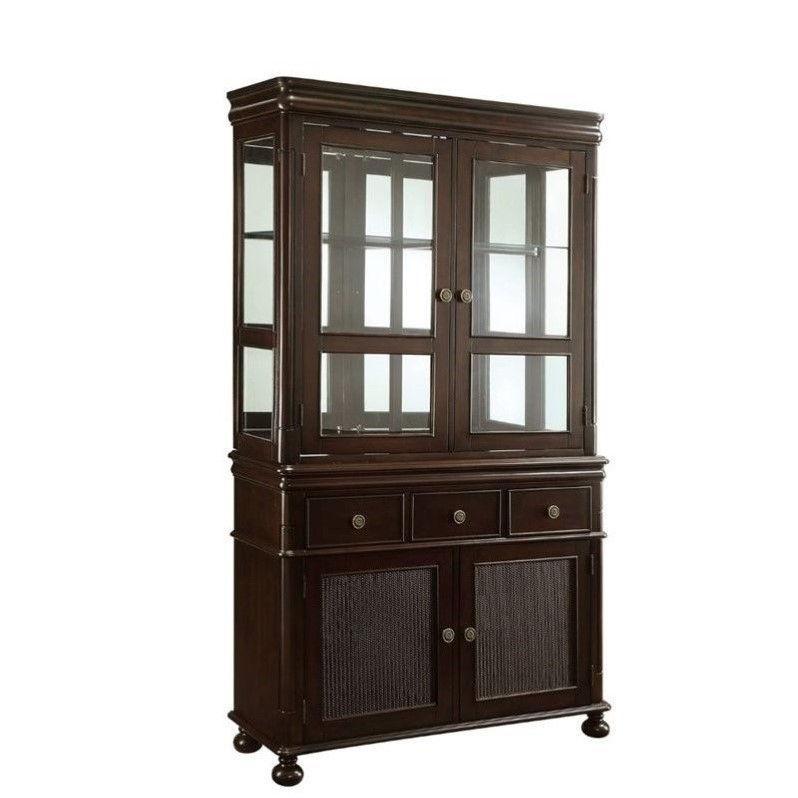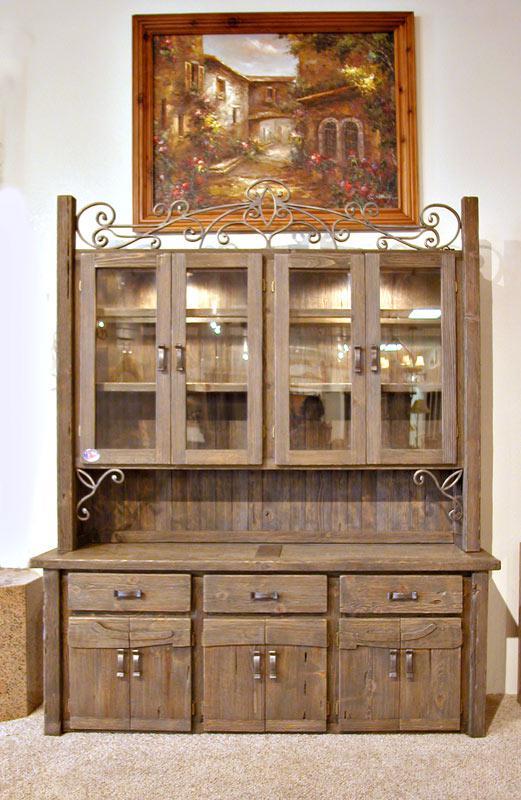The first image is the image on the left, the second image is the image on the right. Evaluate the accuracy of this statement regarding the images: "One of the cabinets has a curving arched solid-wood top.". Is it true? Answer yes or no. No. 